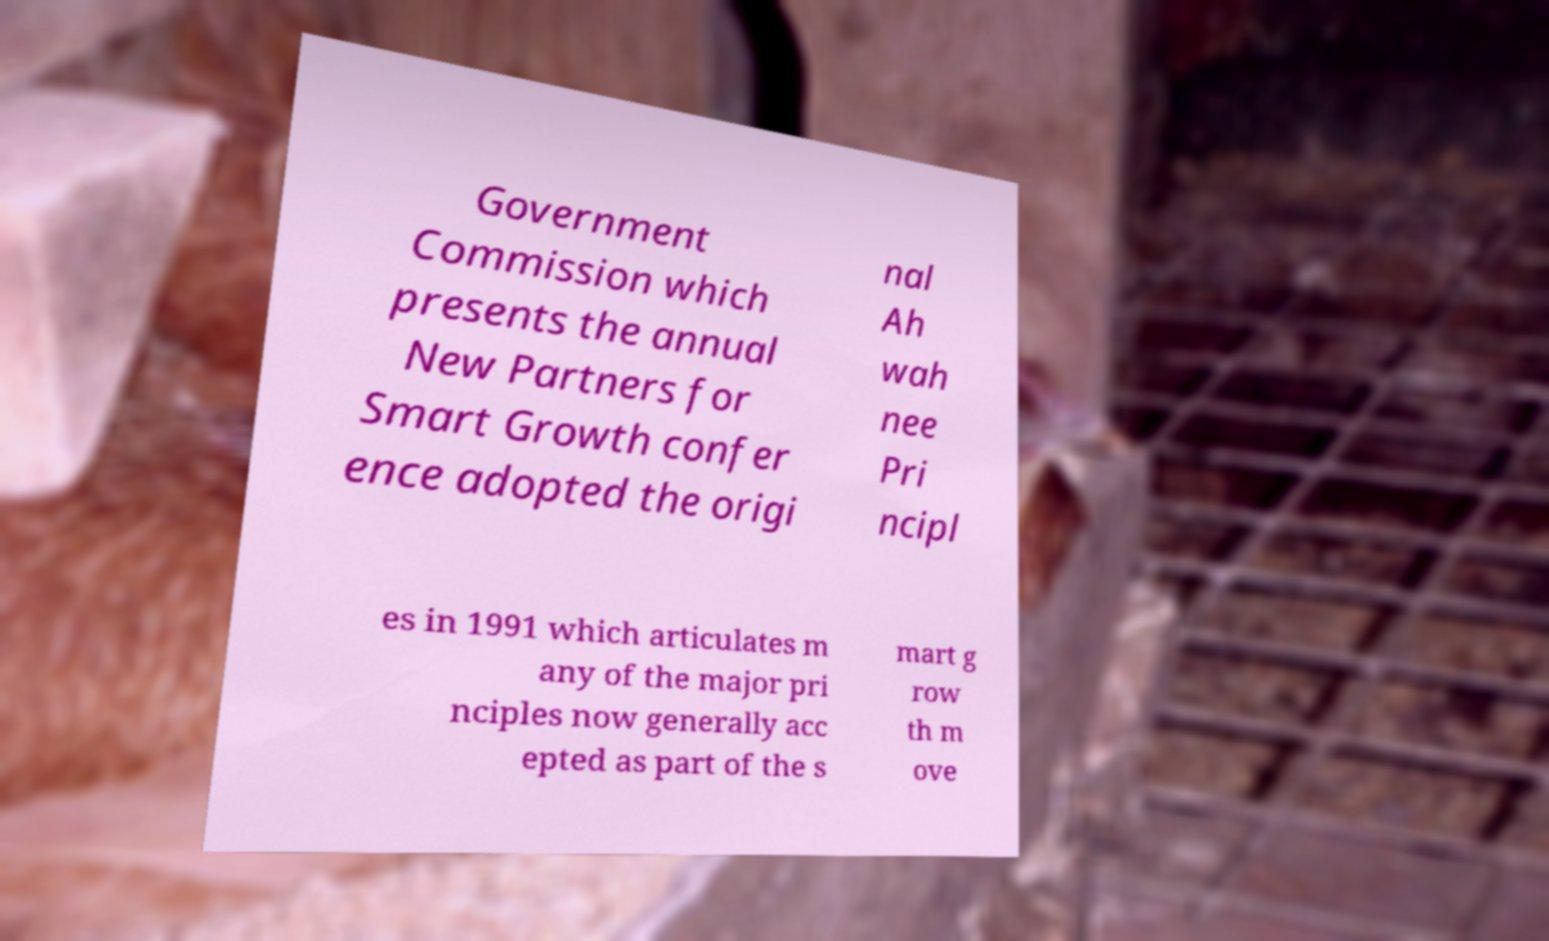I need the written content from this picture converted into text. Can you do that? Government Commission which presents the annual New Partners for Smart Growth confer ence adopted the origi nal Ah wah nee Pri ncipl es in 1991 which articulates m any of the major pri nciples now generally acc epted as part of the s mart g row th m ove 